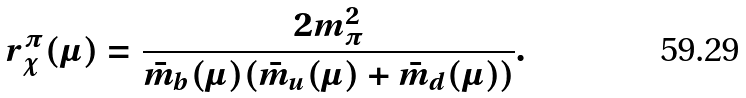Convert formula to latex. <formula><loc_0><loc_0><loc_500><loc_500>r _ { \chi } ^ { \pi } ( \mu ) = \frac { 2 m _ { \pi } ^ { 2 } } { \bar { m } _ { b } ( \mu ) ( \bar { m } _ { u } ( \mu ) + \bar { m } _ { d } ( \mu ) ) } .</formula> 